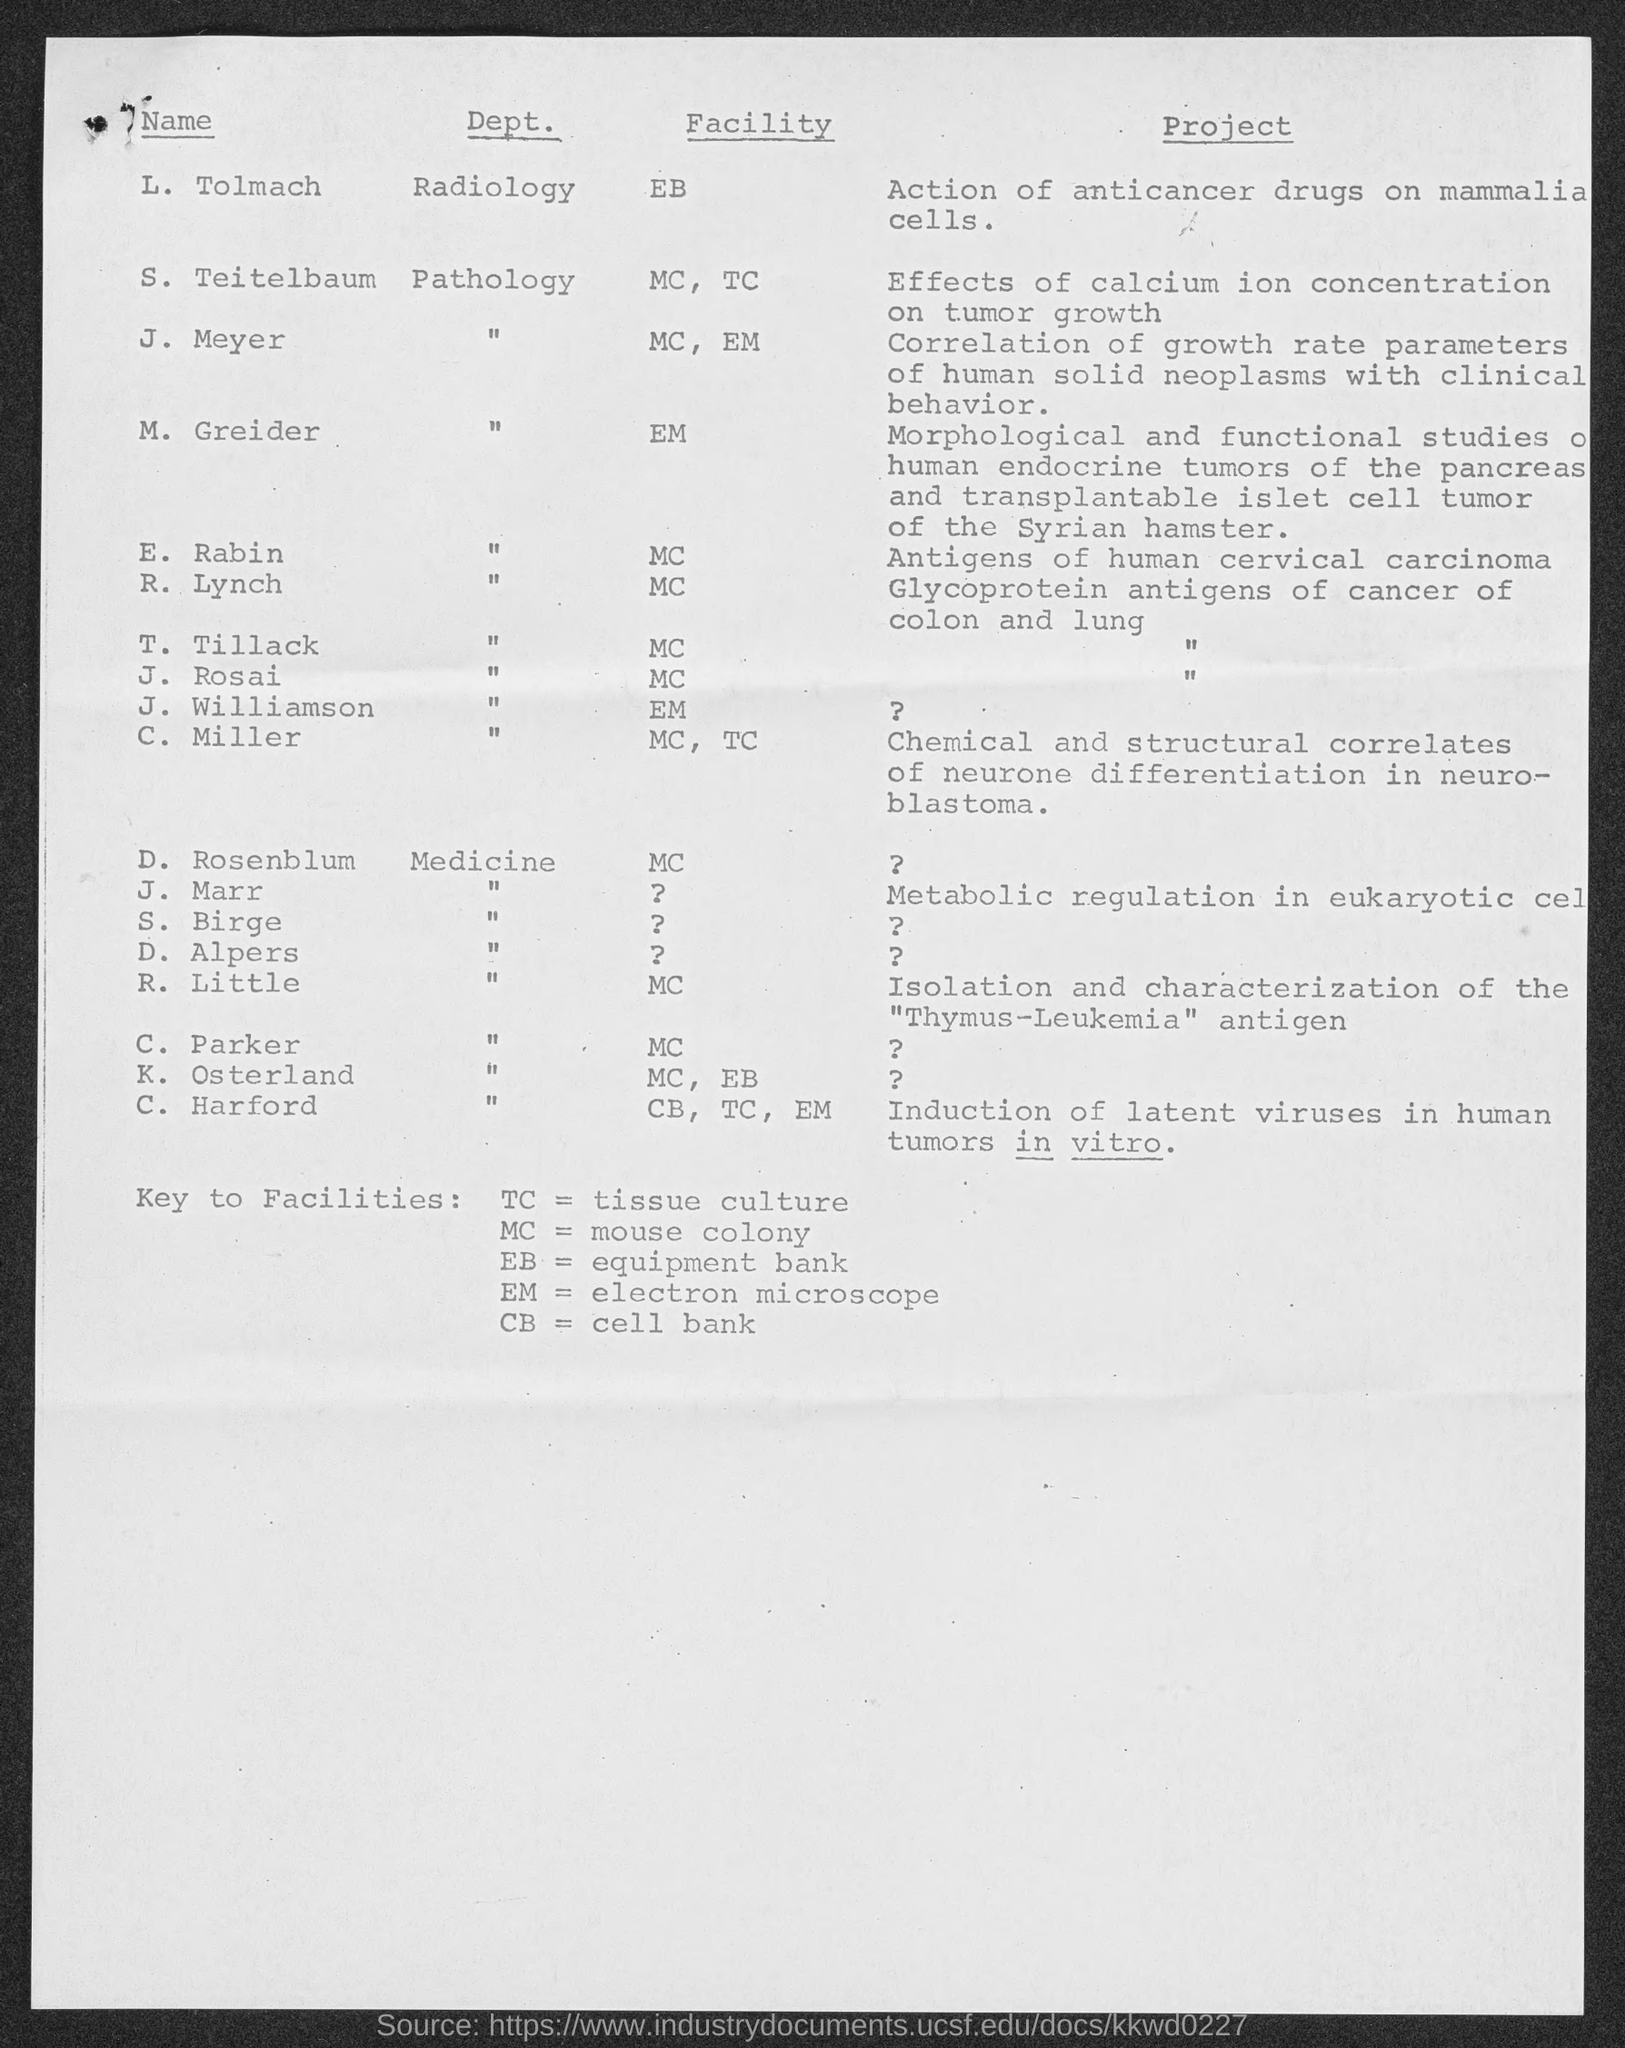Which Facility is L. Tolmach?
Offer a very short reply. EB. Which Facility is J. Meyer?
Your answer should be compact. MC, EM. Which Facility is M. Greider?
Provide a short and direct response. EM. Which Facility is E. Rabin?
Your response must be concise. MC. Which Facility is R. Lynch?
Your response must be concise. MC. Which Facility is T. Tillack?
Ensure brevity in your answer.  MC. Which Facility is J. Rosai?
Provide a short and direct response. MC. Which Facility is J. Williamson?
Your answer should be compact. EM. Which Facility is C. Miller?
Provide a succinct answer. MC, TC. Which Facility is R. Little?
Give a very brief answer. MC. 